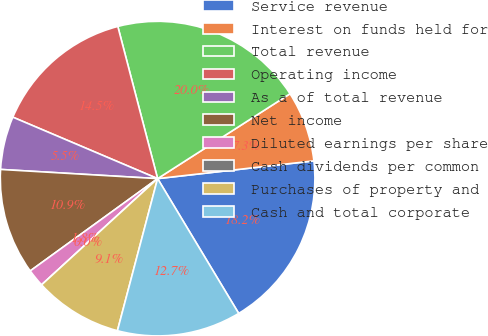Convert chart to OTSL. <chart><loc_0><loc_0><loc_500><loc_500><pie_chart><fcel>Service revenue<fcel>Interest on funds held for<fcel>Total revenue<fcel>Operating income<fcel>As a of total revenue<fcel>Net income<fcel>Diluted earnings per share<fcel>Cash dividends per common<fcel>Purchases of property and<fcel>Cash and total corporate<nl><fcel>18.18%<fcel>7.27%<fcel>20.0%<fcel>14.54%<fcel>5.46%<fcel>10.91%<fcel>1.82%<fcel>0.0%<fcel>9.09%<fcel>12.73%<nl></chart> 